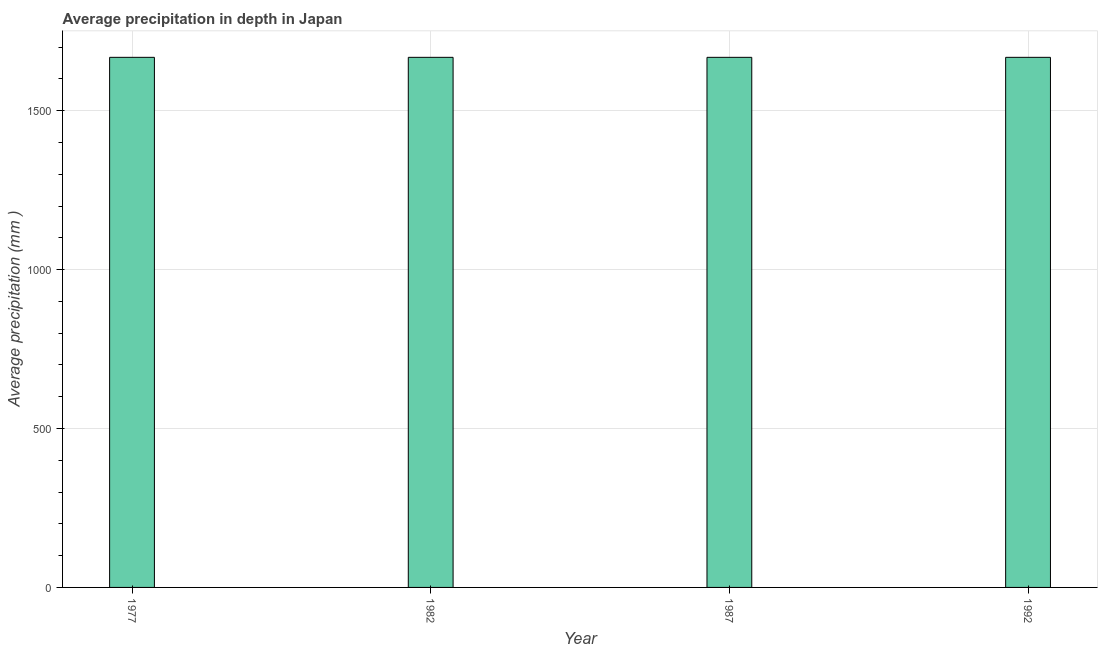Does the graph contain any zero values?
Ensure brevity in your answer.  No. Does the graph contain grids?
Provide a short and direct response. Yes. What is the title of the graph?
Offer a terse response. Average precipitation in depth in Japan. What is the label or title of the X-axis?
Give a very brief answer. Year. What is the label or title of the Y-axis?
Give a very brief answer. Average precipitation (mm ). What is the average precipitation in depth in 1987?
Provide a succinct answer. 1668. Across all years, what is the maximum average precipitation in depth?
Make the answer very short. 1668. Across all years, what is the minimum average precipitation in depth?
Offer a very short reply. 1668. In which year was the average precipitation in depth minimum?
Provide a short and direct response. 1977. What is the sum of the average precipitation in depth?
Make the answer very short. 6672. What is the average average precipitation in depth per year?
Provide a short and direct response. 1668. What is the median average precipitation in depth?
Offer a very short reply. 1668. In how many years, is the average precipitation in depth greater than 700 mm?
Provide a succinct answer. 4. Is the difference between the average precipitation in depth in 1982 and 1992 greater than the difference between any two years?
Your answer should be compact. Yes. Is the sum of the average precipitation in depth in 1977 and 1982 greater than the maximum average precipitation in depth across all years?
Make the answer very short. Yes. In how many years, is the average precipitation in depth greater than the average average precipitation in depth taken over all years?
Your response must be concise. 0. How many bars are there?
Ensure brevity in your answer.  4. Are all the bars in the graph horizontal?
Ensure brevity in your answer.  No. How many years are there in the graph?
Your answer should be compact. 4. What is the difference between two consecutive major ticks on the Y-axis?
Keep it short and to the point. 500. What is the Average precipitation (mm ) in 1977?
Your answer should be very brief. 1668. What is the Average precipitation (mm ) in 1982?
Make the answer very short. 1668. What is the Average precipitation (mm ) of 1987?
Offer a terse response. 1668. What is the Average precipitation (mm ) of 1992?
Give a very brief answer. 1668. What is the difference between the Average precipitation (mm ) in 1977 and 1992?
Ensure brevity in your answer.  0. What is the difference between the Average precipitation (mm ) in 1982 and 1987?
Keep it short and to the point. 0. What is the difference between the Average precipitation (mm ) in 1987 and 1992?
Provide a short and direct response. 0. What is the ratio of the Average precipitation (mm ) in 1977 to that in 1982?
Provide a succinct answer. 1. What is the ratio of the Average precipitation (mm ) in 1977 to that in 1987?
Ensure brevity in your answer.  1. What is the ratio of the Average precipitation (mm ) in 1982 to that in 1987?
Give a very brief answer. 1. 